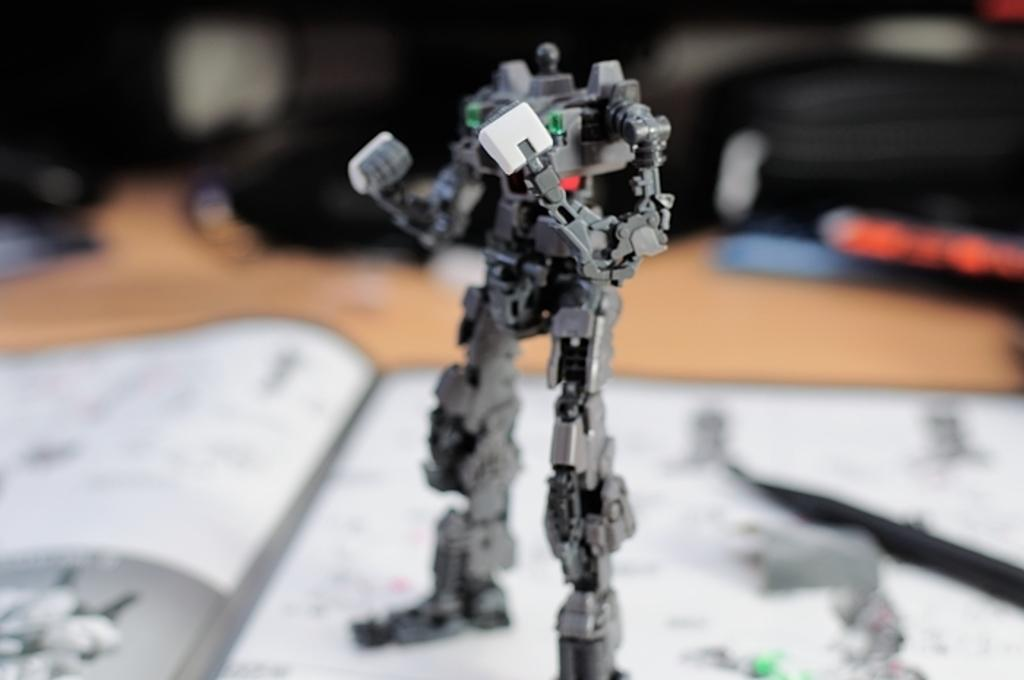What is the main subject of the image? There is a black and white object in the image. Can you describe any other objects or elements in the image? There is a white object in the background of the image. How would you describe the quality of the background in the image? The image is blurry in the background. How many errors can be seen in the image? There is no indication of any errors in the image; it appears to be a clear representation of the objects present. 